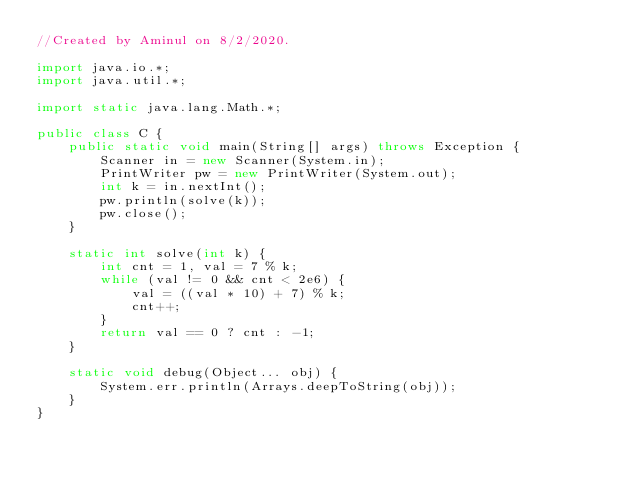Convert code to text. <code><loc_0><loc_0><loc_500><loc_500><_Java_>//Created by Aminul on 8/2/2020.

import java.io.*;
import java.util.*;

import static java.lang.Math.*;

public class C {
    public static void main(String[] args) throws Exception {
        Scanner in = new Scanner(System.in);
        PrintWriter pw = new PrintWriter(System.out);
        int k = in.nextInt();
        pw.println(solve(k));
        pw.close();
    }

    static int solve(int k) {
        int cnt = 1, val = 7 % k;
        while (val != 0 && cnt < 2e6) {
            val = ((val * 10) + 7) % k;
            cnt++;
        }
        return val == 0 ? cnt : -1;
    }

    static void debug(Object... obj) {
        System.err.println(Arrays.deepToString(obj));
    }
}</code> 